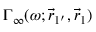<formula> <loc_0><loc_0><loc_500><loc_500>\Gamma _ { \infty } ( \omega ; \vec { r } _ { 1 ^ { \prime } } , \vec { r } _ { 1 } )</formula> 